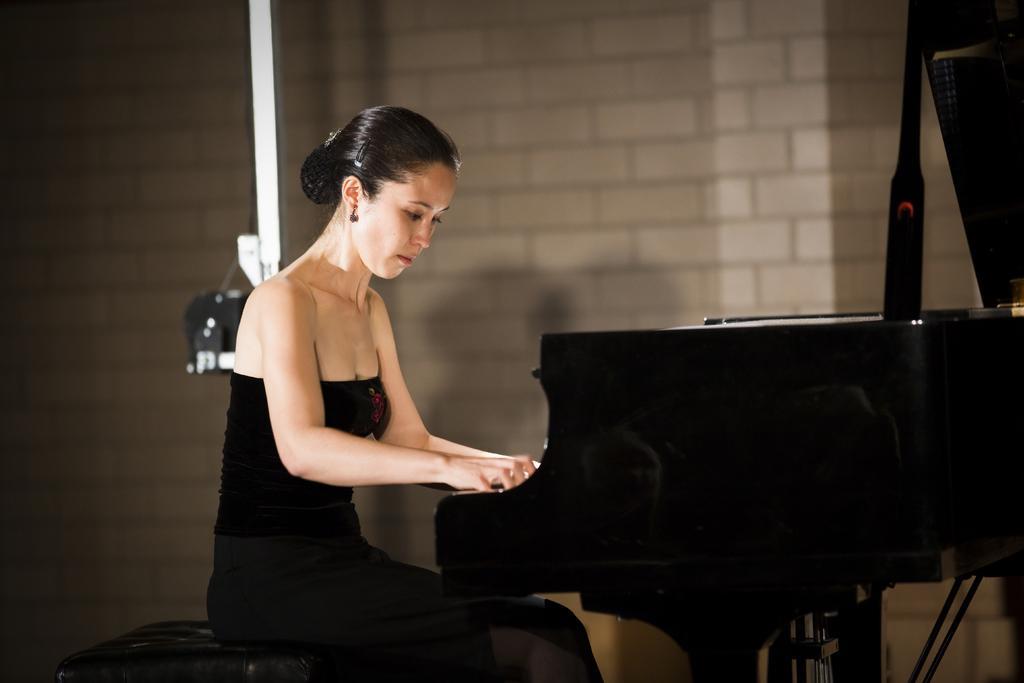How would you summarize this image in a sentence or two? In this image we can see a woman sitting on a sofa and she is playing a piano. 